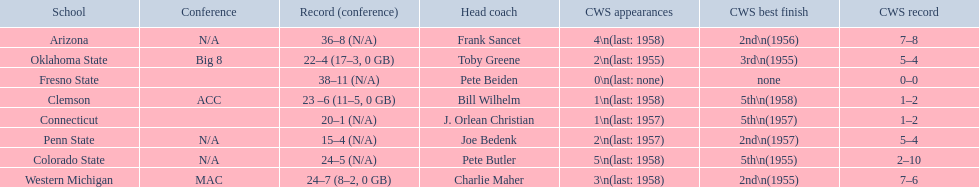What are all the schools? Arizona, Clemson, Colorado State, Connecticut, Fresno State, Oklahoma State, Penn State, Western Michigan. Which are clemson and western michigan? Clemson, Western Michigan. Of these, which has more cws appearances? Western Michigan. 